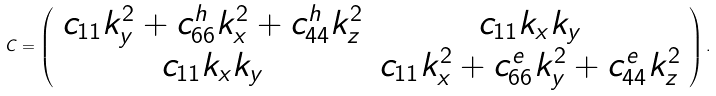<formula> <loc_0><loc_0><loc_500><loc_500>C = \left ( \begin{array} { c c } c _ { 1 1 } k _ { y } ^ { 2 } + c _ { 6 6 } ^ { h } k _ { x } ^ { 2 } + c _ { 4 4 } ^ { h } k _ { z } ^ { 2 } & c _ { 1 1 } k _ { x } k _ { y } \\ c _ { 1 1 } k _ { x } k _ { y } & c _ { 1 1 } k _ { x } ^ { 2 } + c _ { 6 6 } ^ { e } k _ { y } ^ { 2 } + c _ { 4 4 } ^ { e } k _ { z } ^ { 2 } \end{array} \right ) .</formula> 